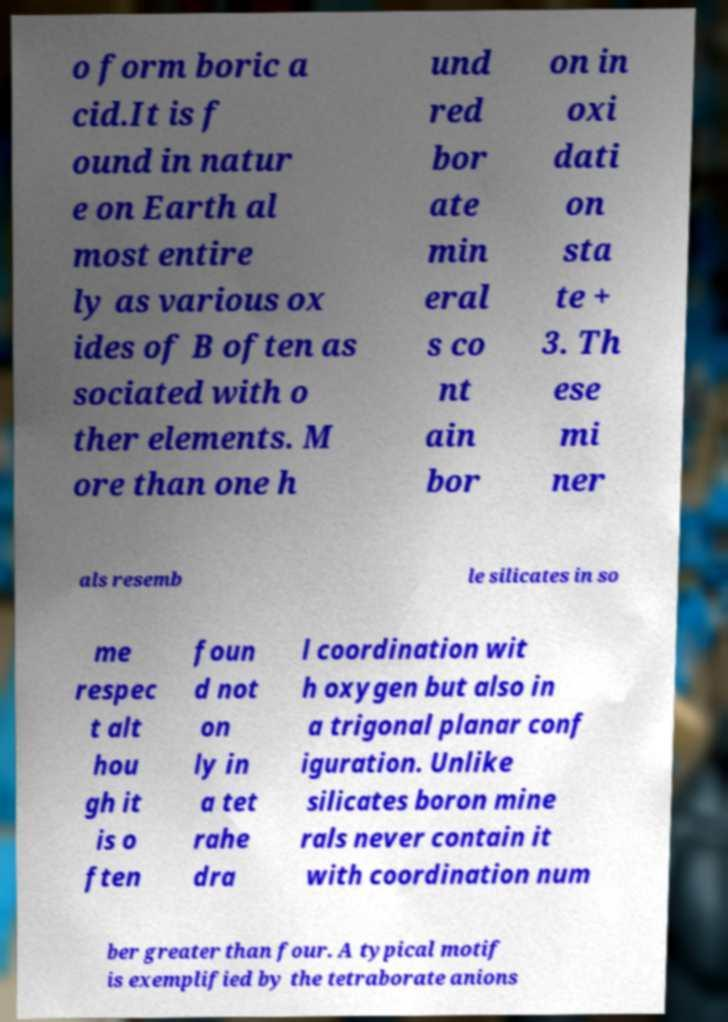For documentation purposes, I need the text within this image transcribed. Could you provide that? o form boric a cid.It is f ound in natur e on Earth al most entire ly as various ox ides of B often as sociated with o ther elements. M ore than one h und red bor ate min eral s co nt ain bor on in oxi dati on sta te + 3. Th ese mi ner als resemb le silicates in so me respec t alt hou gh it is o ften foun d not on ly in a tet rahe dra l coordination wit h oxygen but also in a trigonal planar conf iguration. Unlike silicates boron mine rals never contain it with coordination num ber greater than four. A typical motif is exemplified by the tetraborate anions 